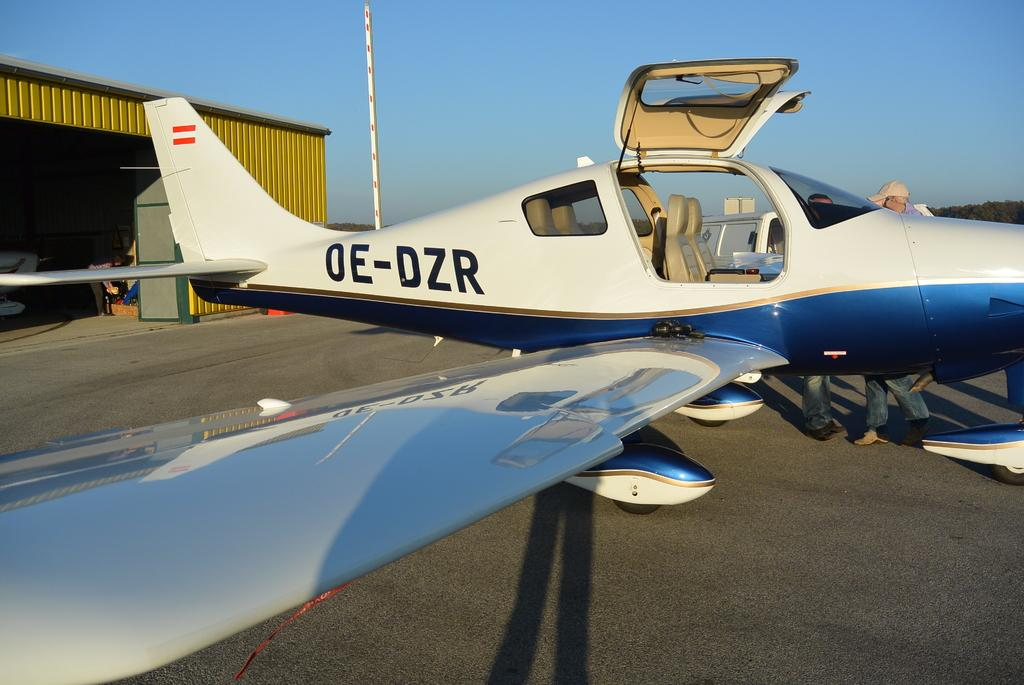<image>
Provide a brief description of the given image. A blue and white plane has OE-DZR on the tail. 